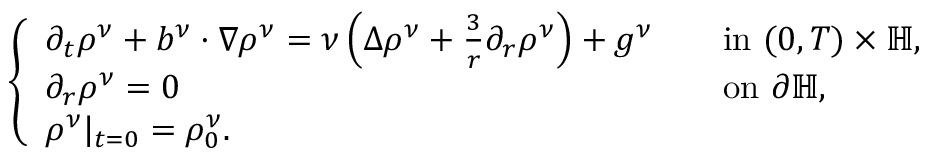<formula> <loc_0><loc_0><loc_500><loc_500>\begin{array} { r } { \left \{ \begin{array} { l l } { \partial _ { t } \rho ^ { \nu } + b ^ { \nu } \cdot \nabla \rho ^ { \nu } = \nu \left ( \Delta \rho ^ { \nu } + \frac { 3 } { r } \partial _ { r } \rho ^ { \nu } \right ) + g ^ { \nu } \quad } & { i n ( 0 , T ) \times \mathbb { H } , } \\ { \partial _ { r } \rho ^ { \nu } = 0 \quad } & { o n \partial \mathbb { H } , } \\ { \rho ^ { \nu } | _ { t = 0 } = \rho _ { 0 } ^ { \nu } . } \end{array} } \end{array}</formula> 